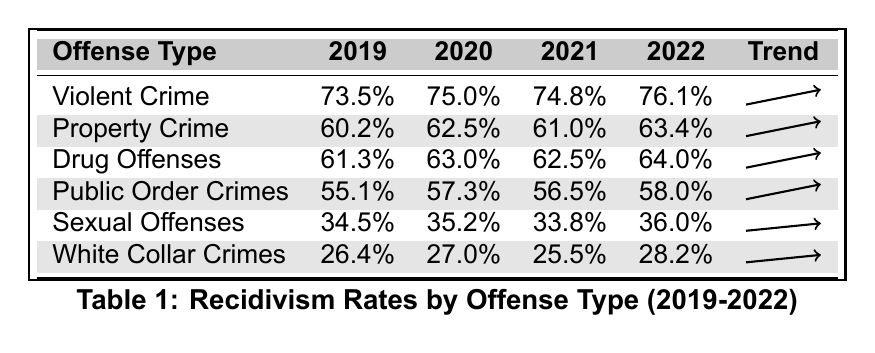What was the recidivism rate for Violent Crime in 2022? The table shows the recidivism rate for Violent Crime in the column for 2022, which is 76.1%.
Answer: 76.1% Which offense type had the highest recidivism rate in 2020? By comparing the rates in the 2020 column, Violent Crime has the highest rate at 75.0%.
Answer: Violent Crime What is the difference in recidivism rates for Property Crime between 2019 and 2022? The recidivism rate for Property Crime in 2019 is 60.2% and in 2022 it is 63.4%. The difference is 63.4% - 60.2% = 3.2%.
Answer: 3.2% Which offense type had the lowest recidivism rate in 2019? The lowest recidivism rate in 2019 can be found in the row for White Collar Crimes, which is 26.4%.
Answer: White Collar Crimes What was the average recidivism rate for Drug Offenses from 2019 to 2022? The rates for Drug Offenses are 61.3%, 63.0%, 62.5%, and 64.0%. Adding these gives 250.8%, and dividing by 4 gives an average of 62.7%.
Answer: 62.7% Is it true that Sexual Offenses had an increase in recidivism rates from 2019 to 2022? The rates for Sexual Offenses are 34.5% in 2019 and 36.0% in 2022. Since 36.0% is greater than 34.5%, there is an increase.
Answer: Yes Which offense type had the smallest increase in recidivism rate between 2019 and 2022? The increases are 2.6% for Violent Crime, 3.2% for Property Crime, 2.7% for Drug Offenses, 2.9% for Public Order Crimes, 1.5% for Sexual Offenses, and 1.8% for White Collar Crimes. The smallest increase is for Sexual Offenses.
Answer: Sexual Offenses What is the combined recidivism rate for Public Order Crimes and White Collar Crimes in 2022? The rates for Public Order Crimes and White Collar Crimes in 2022 are 58.0% and 28.2%, respectively. Adding these gives 58.0% + 28.2% = 86.2%.
Answer: 86.2% In which year did Drug Offenses show the highest recidivism rate? Looking at the Drug Offenses row, the rates are 61.3% in 2019, 63.0% in 2020, 62.5% in 2021, and 64.0% in 2022. The highest rate is in 2022 at 64.0%.
Answer: 2022 What percentage of recidivism did White Collar Crimes show in 2020? The table shows that the recidivism rate for White Collar Crimes in 2020 is 27.0%.
Answer: 27.0% 